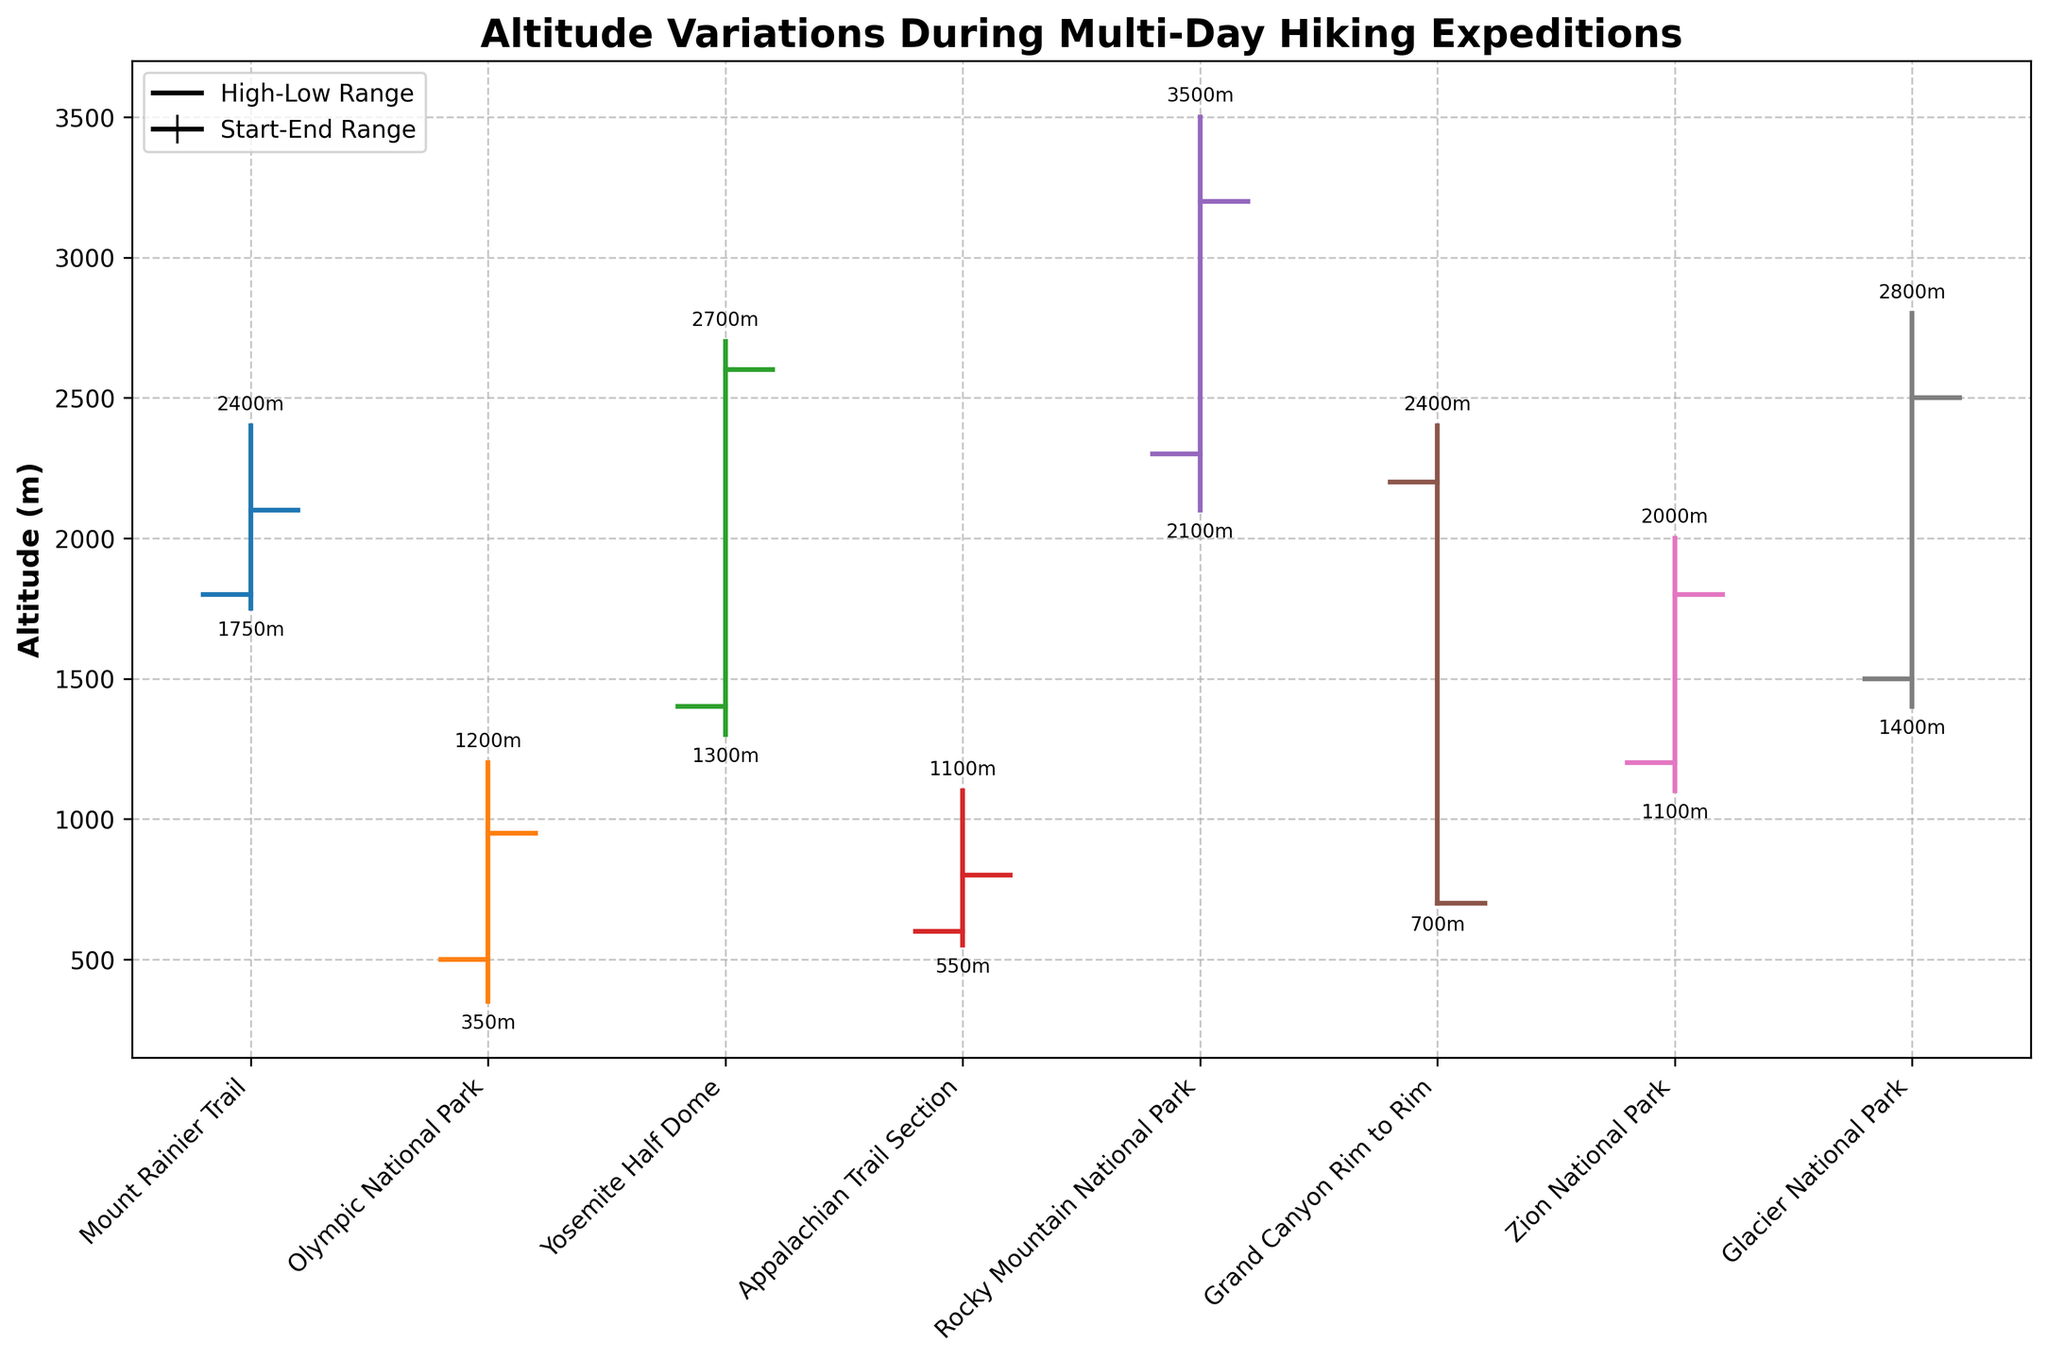Which trail shows the highest maximum elevation? The highest maximum elevation can be identified by looking for the highest "High" marker in the figure. For Rocky Mountain National Park, the maximum elevation is 3500m, which is the highest among all the trails listed.
Answer: Rocky Mountain National Park What is the title of the figure? The title of the figure is typically displayed at the top of the plot and can be read directly.
Answer: Altitude Variations During Multi-Day Hiking Expeditions How many trails are shown in the figure? The number of trails can be counted by looking at the labels on the x-axis of the figure. There are 8 labels, indicating 8 trails.
Answer: 8 Which trail has the biggest difference between its maximum and minimum elevation? To find the trail with the biggest difference between maximum and minimum elevation, calculate the difference for each trail and find the largest. The Grand Canyon Rim to Rim has the largest difference, with a high of 2400m and a low of 700m, giving a difference of 1700m.
Answer: Grand Canyon Rim to Rim On which trail does the starting elevation equal the minimum elevation for that day? By looking at the lines and markers for each trail, we can see if the starting elevation coincides with the lowest point on the plot for that trail. This is seen in the Grand Canyon Rim to Rim trail where both start and low elevations are 2200m and 700m respectively.
Answer: None Which trail has an ending elevation lower than its starting elevation? Check the plots where the ending elevation marker is below the starting elevation marker. Mount Rainier Trail and Olympic National Park show ending elevations lower than their starting elevations.
Answer: Mount Rainier Trail and Olympic National Park What is the average ending elevation of all the trails? To calculate the average ending elevation, sum all the ending elevations and divide by the number of trails. The sum of ending elevations is 2100 + 950 + 2600 + 800 + 3200 + 700 + 1800 + 2500 = 15750. Dividing by 8 trails gives an average of 1968.75m.
Answer: 1968.75m Compare the elevation variation of Yosemite Half Dome and Glacier National Park. Which one has a greater range? Calculate the range (maximum elevation minus minimum elevation) for each trail. Yosemite Half Dome has a range of 2700m - 1300m = 1400m, and Glacier National Park has a range of 2800m - 1400m = 1400m. Both have the same range.
Answer: Same range (1400m) What is the lowest elevation point among all the trails? The lowest elevation can be found by identifying the lowest "Low" point in the figure. The Grand Canyon Rim to Rim has the lowest elevation at 700m.
Answer: 700m Which trail showed no overall change in elevation from start to end? Identify the trail where the start and end elevations are equal. The Grand Canyon Rim to Rim starts and ends at 700m, showing no overall change in elevation.
Answer: Grand Canyon Rim to Rim 